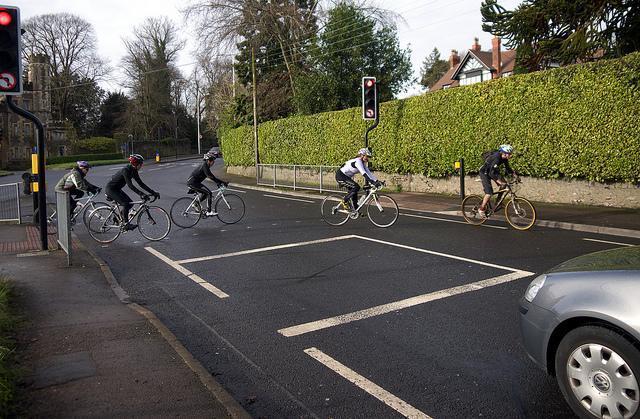How many birds are there?
Give a very brief answer. 0. 